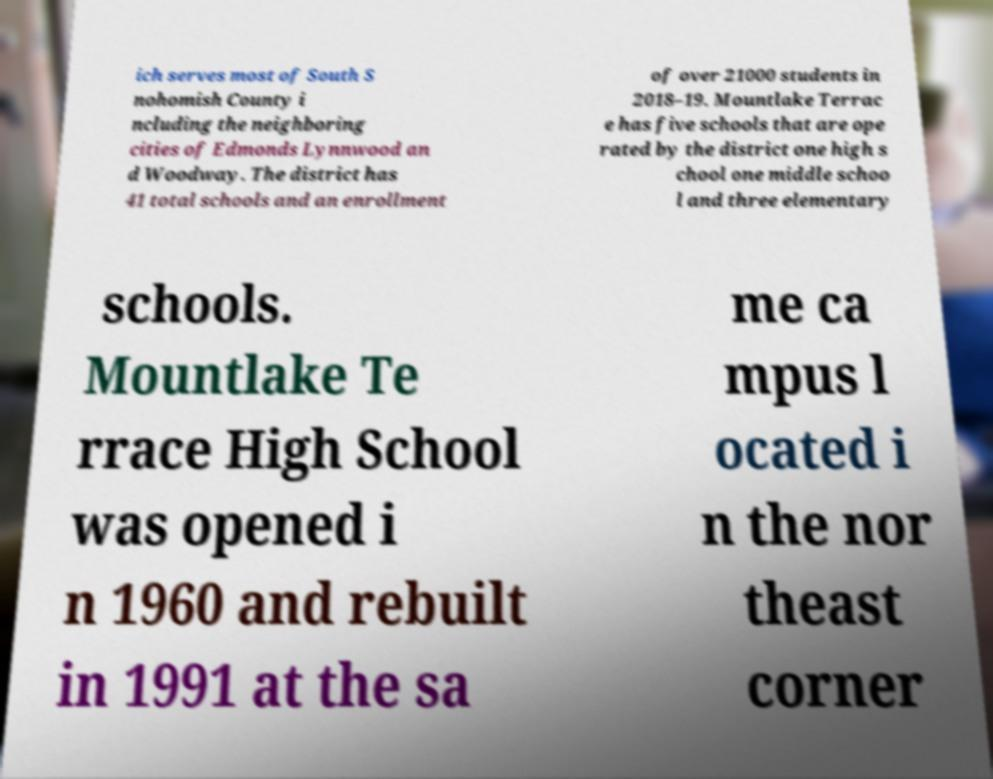Can you read and provide the text displayed in the image?This photo seems to have some interesting text. Can you extract and type it out for me? ich serves most of South S nohomish County i ncluding the neighboring cities of Edmonds Lynnwood an d Woodway. The district has 41 total schools and an enrollment of over 21000 students in 2018–19. Mountlake Terrac e has five schools that are ope rated by the district one high s chool one middle schoo l and three elementary schools. Mountlake Te rrace High School was opened i n 1960 and rebuilt in 1991 at the sa me ca mpus l ocated i n the nor theast corner 